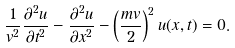Convert formula to latex. <formula><loc_0><loc_0><loc_500><loc_500>\frac { 1 } { v ^ { 2 } } \frac { \partial ^ { 2 } u } { \partial t ^ { 2 } } - \frac { \partial ^ { 2 } u } { \partial x ^ { 2 } } - \left ( \frac { m v } { 2 } \right ) ^ { 2 } u ( x , t ) = 0 .</formula> 